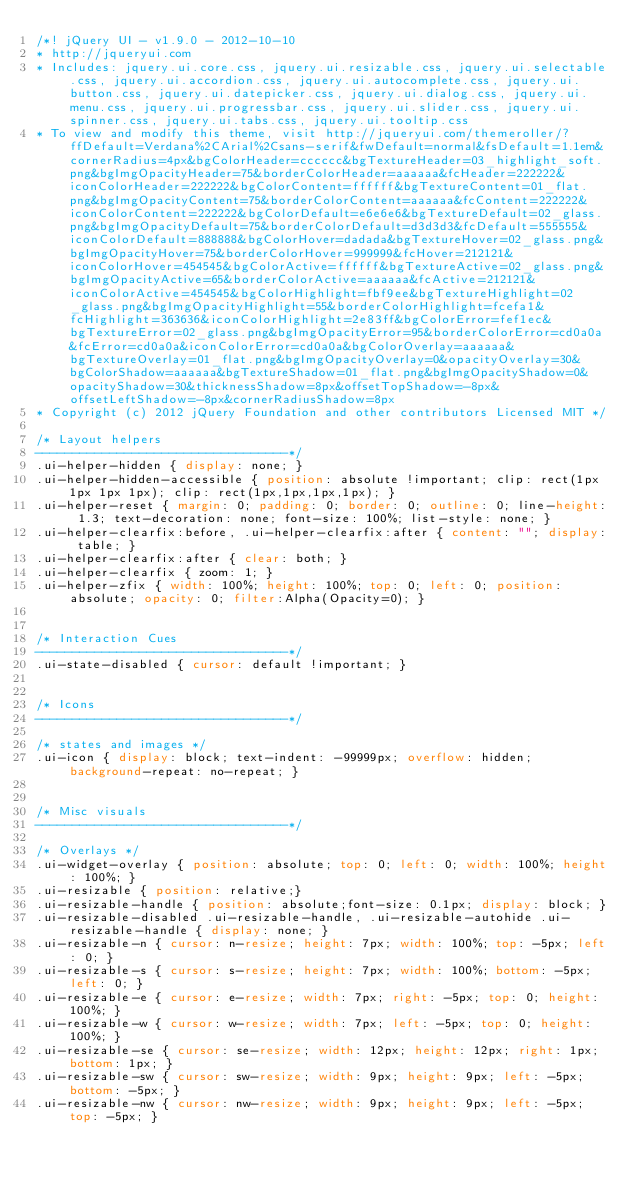Convert code to text. <code><loc_0><loc_0><loc_500><loc_500><_CSS_>/*! jQuery UI - v1.9.0 - 2012-10-10
* http://jqueryui.com
* Includes: jquery.ui.core.css, jquery.ui.resizable.css, jquery.ui.selectable.css, jquery.ui.accordion.css, jquery.ui.autocomplete.css, jquery.ui.button.css, jquery.ui.datepicker.css, jquery.ui.dialog.css, jquery.ui.menu.css, jquery.ui.progressbar.css, jquery.ui.slider.css, jquery.ui.spinner.css, jquery.ui.tabs.css, jquery.ui.tooltip.css
* To view and modify this theme, visit http://jqueryui.com/themeroller/?ffDefault=Verdana%2CArial%2Csans-serif&fwDefault=normal&fsDefault=1.1em&cornerRadius=4px&bgColorHeader=cccccc&bgTextureHeader=03_highlight_soft.png&bgImgOpacityHeader=75&borderColorHeader=aaaaaa&fcHeader=222222&iconColorHeader=222222&bgColorContent=ffffff&bgTextureContent=01_flat.png&bgImgOpacityContent=75&borderColorContent=aaaaaa&fcContent=222222&iconColorContent=222222&bgColorDefault=e6e6e6&bgTextureDefault=02_glass.png&bgImgOpacityDefault=75&borderColorDefault=d3d3d3&fcDefault=555555&iconColorDefault=888888&bgColorHover=dadada&bgTextureHover=02_glass.png&bgImgOpacityHover=75&borderColorHover=999999&fcHover=212121&iconColorHover=454545&bgColorActive=ffffff&bgTextureActive=02_glass.png&bgImgOpacityActive=65&borderColorActive=aaaaaa&fcActive=212121&iconColorActive=454545&bgColorHighlight=fbf9ee&bgTextureHighlight=02_glass.png&bgImgOpacityHighlight=55&borderColorHighlight=fcefa1&fcHighlight=363636&iconColorHighlight=2e83ff&bgColorError=fef1ec&bgTextureError=02_glass.png&bgImgOpacityError=95&borderColorError=cd0a0a&fcError=cd0a0a&iconColorError=cd0a0a&bgColorOverlay=aaaaaa&bgTextureOverlay=01_flat.png&bgImgOpacityOverlay=0&opacityOverlay=30&bgColorShadow=aaaaaa&bgTextureShadow=01_flat.png&bgImgOpacityShadow=0&opacityShadow=30&thicknessShadow=8px&offsetTopShadow=-8px&offsetLeftShadow=-8px&cornerRadiusShadow=8px
* Copyright (c) 2012 jQuery Foundation and other contributors Licensed MIT */

/* Layout helpers
----------------------------------*/
.ui-helper-hidden { display: none; }
.ui-helper-hidden-accessible { position: absolute !important; clip: rect(1px 1px 1px 1px); clip: rect(1px,1px,1px,1px); }
.ui-helper-reset { margin: 0; padding: 0; border: 0; outline: 0; line-height: 1.3; text-decoration: none; font-size: 100%; list-style: none; }
.ui-helper-clearfix:before, .ui-helper-clearfix:after { content: ""; display: table; }
.ui-helper-clearfix:after { clear: both; }
.ui-helper-clearfix { zoom: 1; }
.ui-helper-zfix { width: 100%; height: 100%; top: 0; left: 0; position: absolute; opacity: 0; filter:Alpha(Opacity=0); }


/* Interaction Cues
----------------------------------*/
.ui-state-disabled { cursor: default !important; }


/* Icons
----------------------------------*/

/* states and images */
.ui-icon { display: block; text-indent: -99999px; overflow: hidden; background-repeat: no-repeat; }


/* Misc visuals
----------------------------------*/

/* Overlays */
.ui-widget-overlay { position: absolute; top: 0; left: 0; width: 100%; height: 100%; }
.ui-resizable { position: relative;}
.ui-resizable-handle { position: absolute;font-size: 0.1px; display: block; }
.ui-resizable-disabled .ui-resizable-handle, .ui-resizable-autohide .ui-resizable-handle { display: none; }
.ui-resizable-n { cursor: n-resize; height: 7px; width: 100%; top: -5px; left: 0; }
.ui-resizable-s { cursor: s-resize; height: 7px; width: 100%; bottom: -5px; left: 0; }
.ui-resizable-e { cursor: e-resize; width: 7px; right: -5px; top: 0; height: 100%; }
.ui-resizable-w { cursor: w-resize; width: 7px; left: -5px; top: 0; height: 100%; }
.ui-resizable-se { cursor: se-resize; width: 12px; height: 12px; right: 1px; bottom: 1px; }
.ui-resizable-sw { cursor: sw-resize; width: 9px; height: 9px; left: -5px; bottom: -5px; }
.ui-resizable-nw { cursor: nw-resize; width: 9px; height: 9px; left: -5px; top: -5px; }</code> 